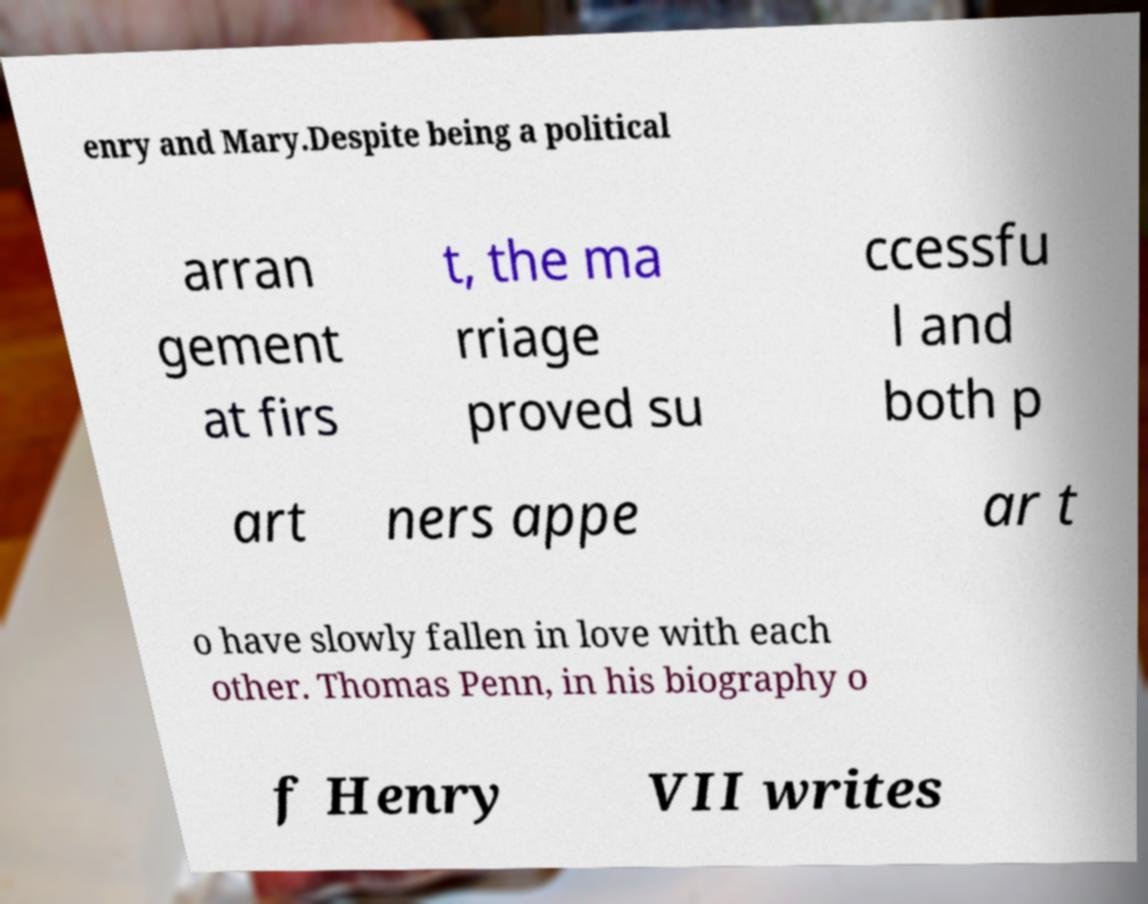Please identify and transcribe the text found in this image. enry and Mary.Despite being a political arran gement at firs t, the ma rriage proved su ccessfu l and both p art ners appe ar t o have slowly fallen in love with each other. Thomas Penn, in his biography o f Henry VII writes 